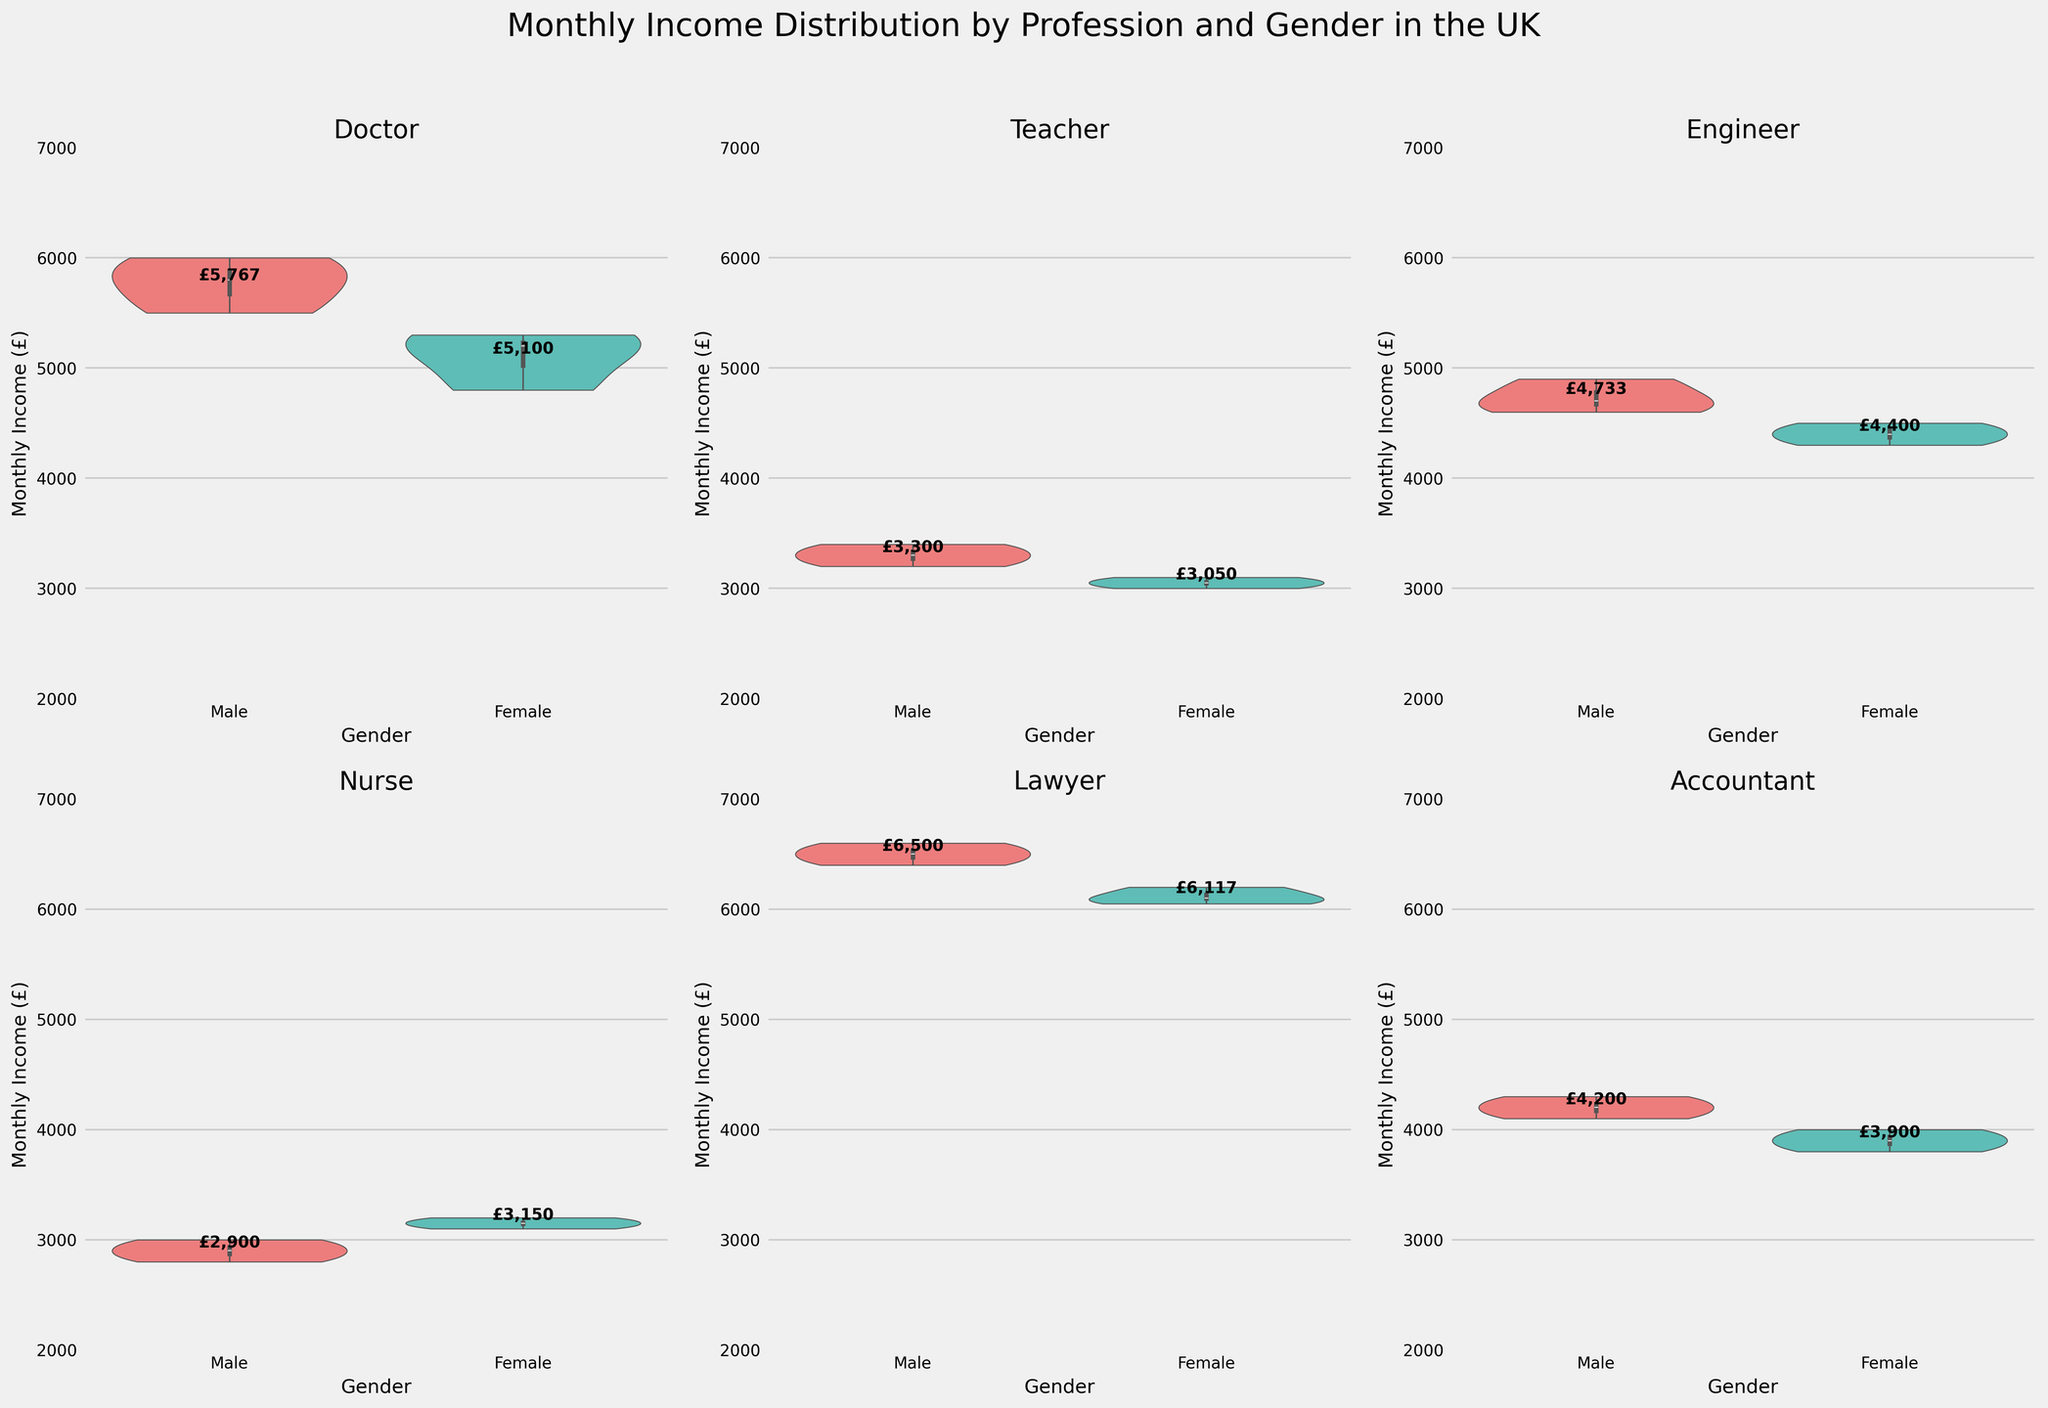What is the title of the figure? The title is located at the top of the figure, summarizing its content. It states what the figure is about. The complete title text reads: 'Monthly Income Distribution by Profession and Gender in the UK'.
Answer: 'Monthly Income Distribution by Profession and Gender in the UK' What is the range of Monthly Income shown for teachers? Each subplot represents a profession, and the y-axis shows the Monthly Income range. For teachers, the y-axis indicates values starting from £2000 up to £7000. However, the actual violin plot for teachers shows income values between approximately £3000 and £3400.
Answer: £3000 to £3400 Which profession shows the highest average income for males? We look at the mean income text annotation for each male violin plot across all professions. For doctors, it’s £5767, teachers – £3300, engineers – £4733, nurses – £2900, lawyers – £6500, and accountants – £4200. The highest value is £6500 for lawyers.
Answer: Lawyers What is the gender-based income gap for engineers (difference in mean income)? Locate the engineer's subplot and note the mean incomes: £4733 for males and £4400 for females. To find the gap, subtract the female mean income from the male mean income: £4733 - £4400 = £333.
Answer: £333 Which profession has the smallest difference in monthly income between males and females? Examine the mean income annotations in each subplot. The professions with the smallest differences are nurses (£2900 - £3075 = £-175) and teachers (£3300 - £3050 = £250). The smallest gap is for nurses at £-175.
Answer: Nurses How does the income range for female doctors compare to female lawyers? The two relevant subplots are Doctors and Lawyers. The female doctors' income distribution ranges from approximately £4800 to £5300, while the female lawyers' range is roughly from £6050 to £6200.
Answer: Female lawyers have a higher and narrower range On average, which profession has the highest income for females? Look at the mean income text annotations for females in each violin plot. For doctors, it’s £5100, teachers – £3050, engineers – £4400, nurses – £3075, lawyers – £6117, and accountants – £3900. The highest value is £6117 for lawyers.
Answer: Lawyers Which gender has a generally higher monthly income for the accounting profession? In the accounting subplot, compare the mean income text annotations: £4200 for males and £3900 for females. Males have a higher income on average.
Answer: Male What is the average monthly income for male nurses? Look at the mean income indicated on the male nurses' violin plot. The exact text annotation identifies it as £2900.
Answer: £2900 How does the income variability for male teachers compare to male lawyers? Compare the spread of the violin plots. The range for male teachers is from about £3200 to £3400, whereas for male lawyers it spans from about £6400 to £6600. The income variability for male teachers is less compared to male lawyers.
Answer: Male teachers have less variability 